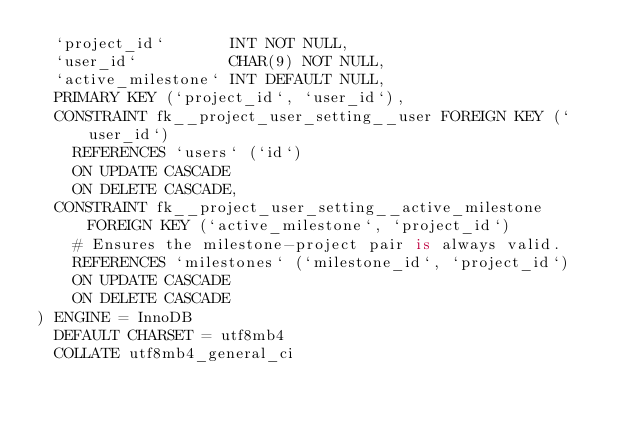<code> <loc_0><loc_0><loc_500><loc_500><_SQL_>	`project_id`       INT NOT NULL,
	`user_id`          CHAR(9) NOT NULL,
	`active_milestone` INT DEFAULT NULL,
	PRIMARY KEY (`project_id`, `user_id`),
	CONSTRAINT fk__project_user_setting__user FOREIGN KEY (`user_id`)
		REFERENCES `users` (`id`)
		ON UPDATE CASCADE
		ON DELETE CASCADE,
	CONSTRAINT fk__project_user_setting__active_milestone FOREIGN KEY (`active_milestone`, `project_id`)
		# Ensures the milestone-project pair is always valid.
		REFERENCES `milestones` (`milestone_id`, `project_id`)
		ON UPDATE CASCADE
		ON DELETE CASCADE
) ENGINE = InnoDB
  DEFAULT CHARSET = utf8mb4
  COLLATE utf8mb4_general_ci
</code> 